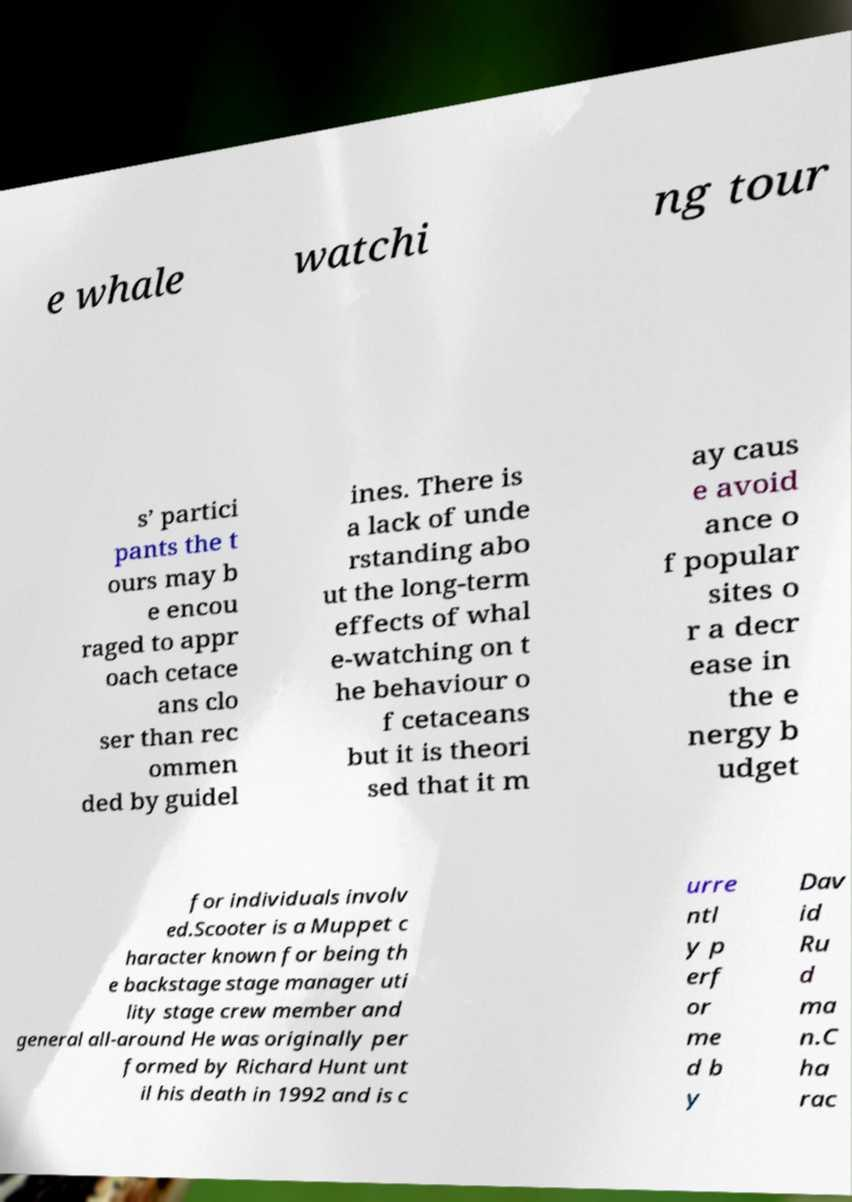Please read and relay the text visible in this image. What does it say? e whale watchi ng tour s’ partici pants the t ours may b e encou raged to appr oach cetace ans clo ser than rec ommen ded by guidel ines. There is a lack of unde rstanding abo ut the long-term effects of whal e-watching on t he behaviour o f cetaceans but it is theori sed that it m ay caus e avoid ance o f popular sites o r a decr ease in the e nergy b udget for individuals involv ed.Scooter is a Muppet c haracter known for being th e backstage stage manager uti lity stage crew member and general all-around He was originally per formed by Richard Hunt unt il his death in 1992 and is c urre ntl y p erf or me d b y Dav id Ru d ma n.C ha rac 